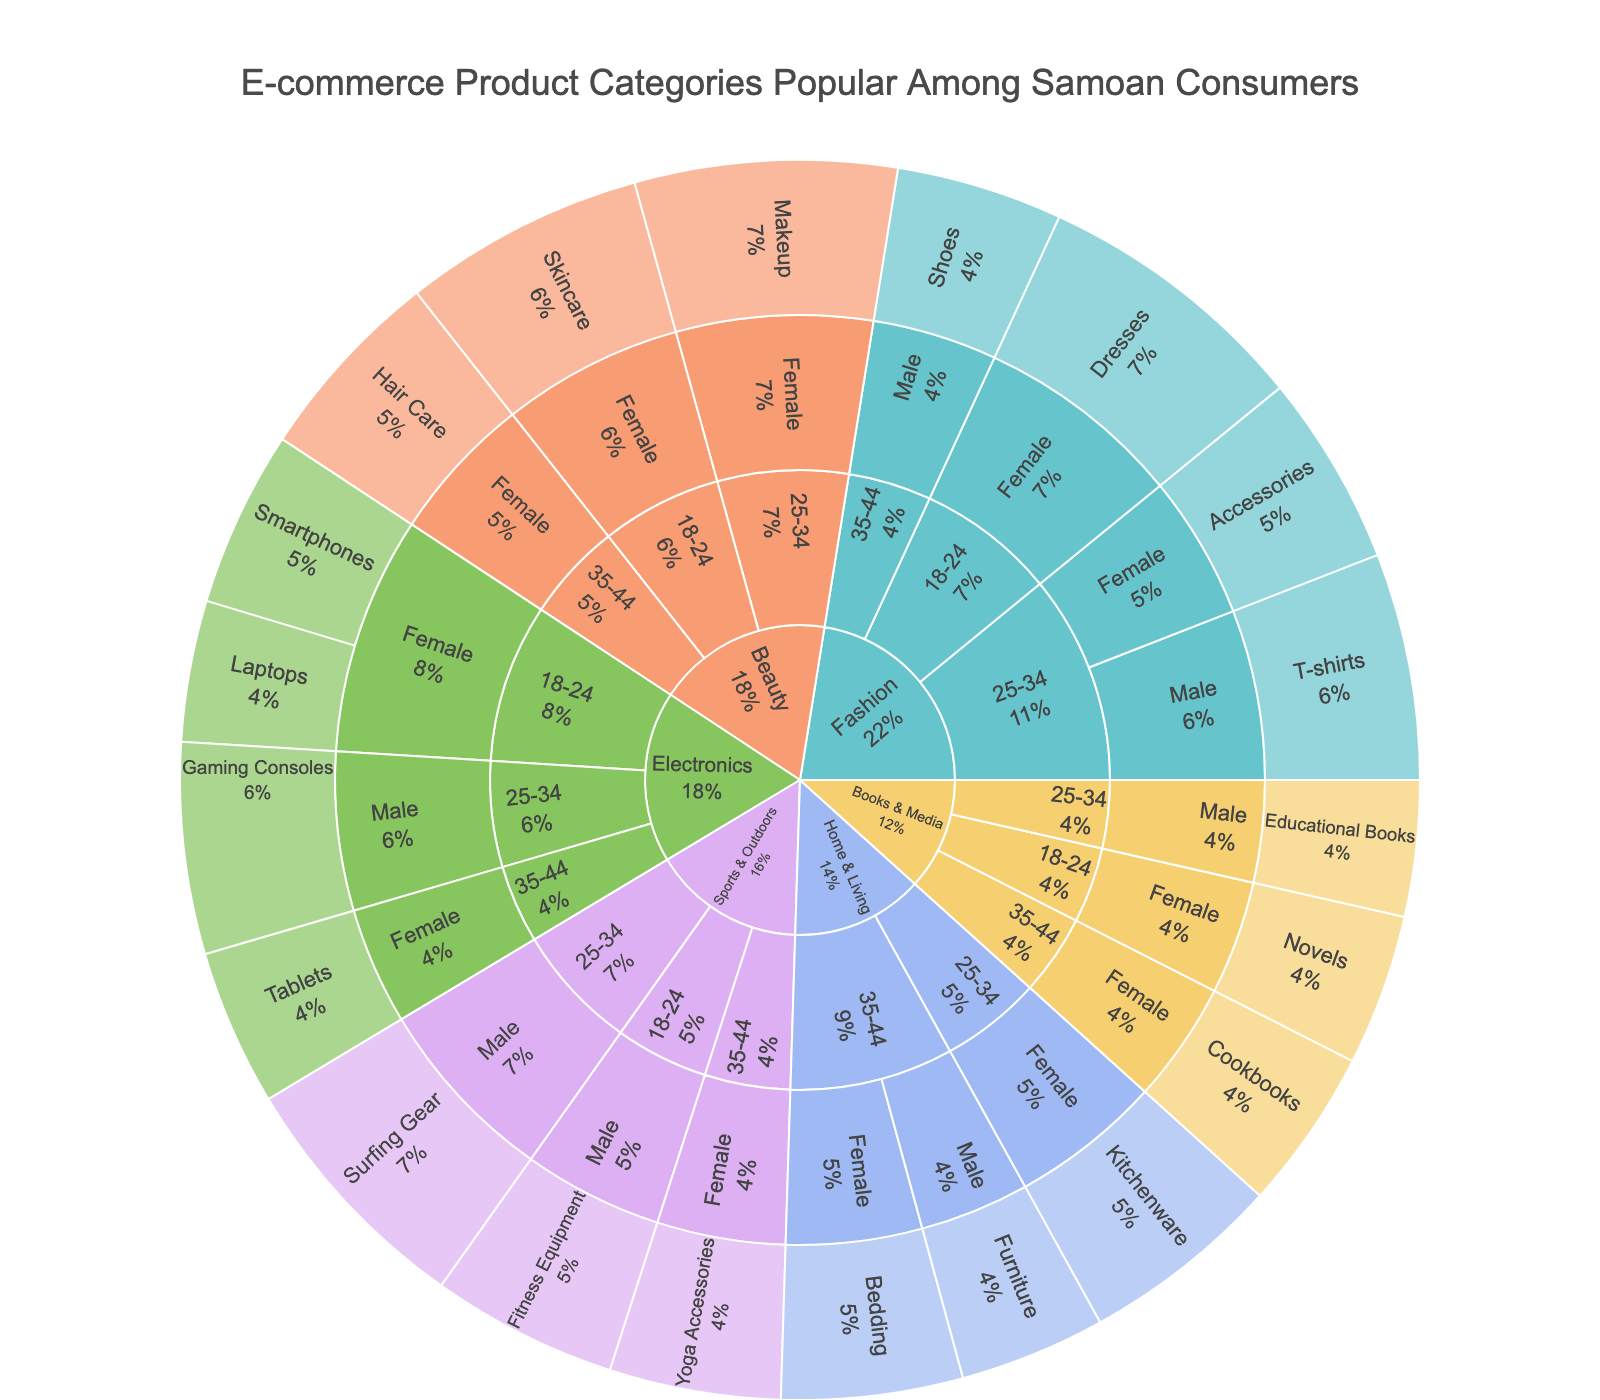What is the title of the Sunburst Plot? The title of a Sunburst Plot is usually located at the top center of the figure. In this case, it is "E-commerce Product Categories Popular Among Samoan Consumers."
Answer: E-commerce Product Categories Popular Among Samoan Consumers Which product category has the highest total value for Samoan consumers aged 18-24? By examining the segments of the Sunburst Plot, you can see that the category "Fashion" has a sizable segment for the 18-24 age group. Summing up the values within this category, you have Dresses with a value of 55.
Answer: Fashion How many distinct product categories are represented in the plot? To find the number of distinct product categories, look at the outermost layer of the Sunburst Plot and count the unique categories. These are Electronics, Fashion, Home & Living, Beauty, Sports & Outdoors, and Books & Media.
Answer: 6 What is the most popular product among females aged 25-34? Navigate to the "25-34" age group under the female category and inspect the segments for different products. The product with the highest value here is Makeup with a value of 52.
Answer: Makeup Compare the popularity of Gaming Consoles among males aged 25-34 to Skincare products among females aged 18-24. Which is more popular? Look at the segment for Gaming Consoles under the 25-34 age group for males (value of 42) and compare it to the segment for Skincare under the 18-24 age group for females (value of 48). The Skincare products are more popular.
Answer: Skincare products among females aged 18-24 Which age group has the highest total value for the Beauty category? To find this, sum up the values for the 18-24, 25-34, and 35-44 age groups within the Beauty category. Each segment can be observed as follows: Skincare (48), Makeup (52), and Hair Care (39). The highest value comes from the 25-34 age group.
Answer: 25-34 What is the combined value of T-shirts and Surfing Gear? Locate the values for T-shirts and Surfing Gear in the plot (T-shirts: 45, Surfing Gear: 50). Add these values together. 45 + 50 = 95.
Answer: 95 Which gender shows a higher interest in Home & Living products among Samoan consumers aged 35-44? Within the age group 35-44, check the segments for males and females in the Home & Living category. Female values for Bedding and Furniture add up to 36 + 29 = 65. Females have a higher interest.
Answer: Female In the entire plot, which age group shows the least interest in Electronics? Compare the segments of electronics for each age group: 18-24, 25-34, and 35-44. Sum the values for each age group: 18-24 (35+28=63), 25-34 (42), 35-44 (31). The 35-44 age group shows the least interest.
Answer: 35-44 